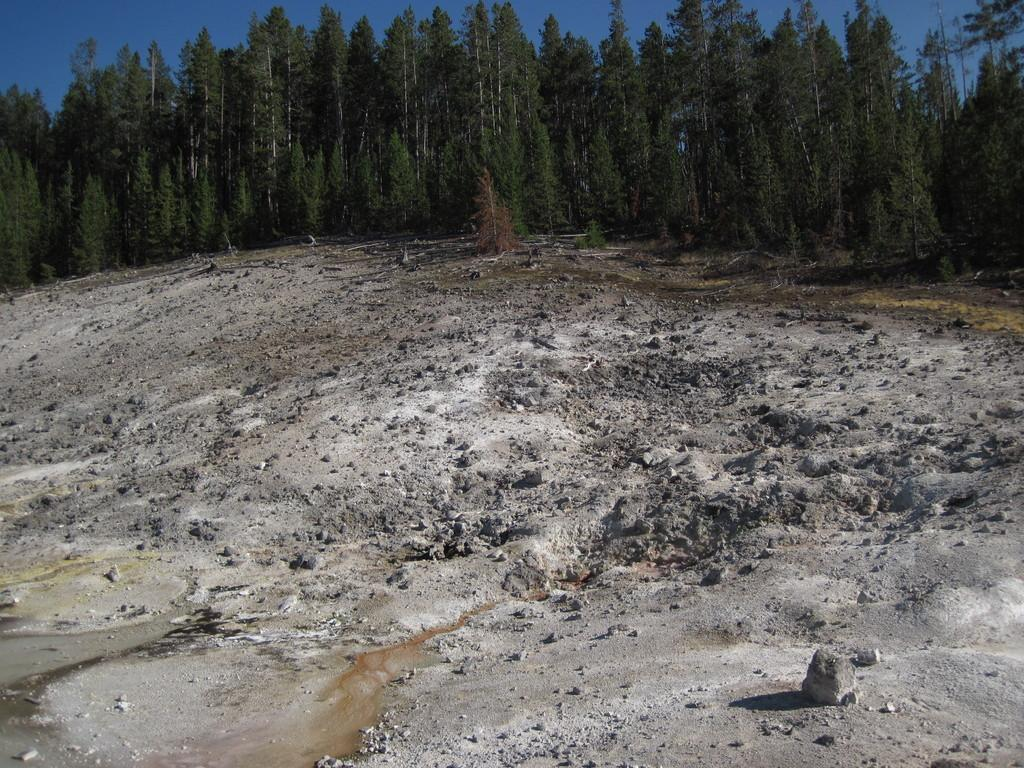What can be seen in the background of the image? There is a sky and trees visible in the background of the image. What is the land area in the image covered with? The land area in the image is covered with stones and pebbles. How many hydrants can be seen in the image? There are no hydrants present in the image. What color are the eyes of the trees in the image? Trees do not have eyes, so this question cannot be answered. 